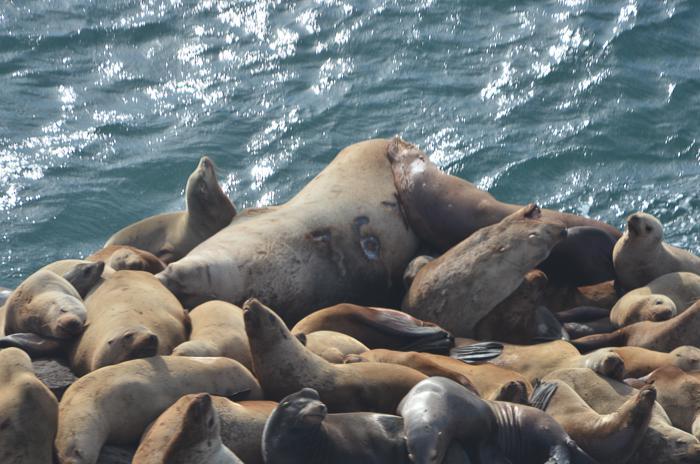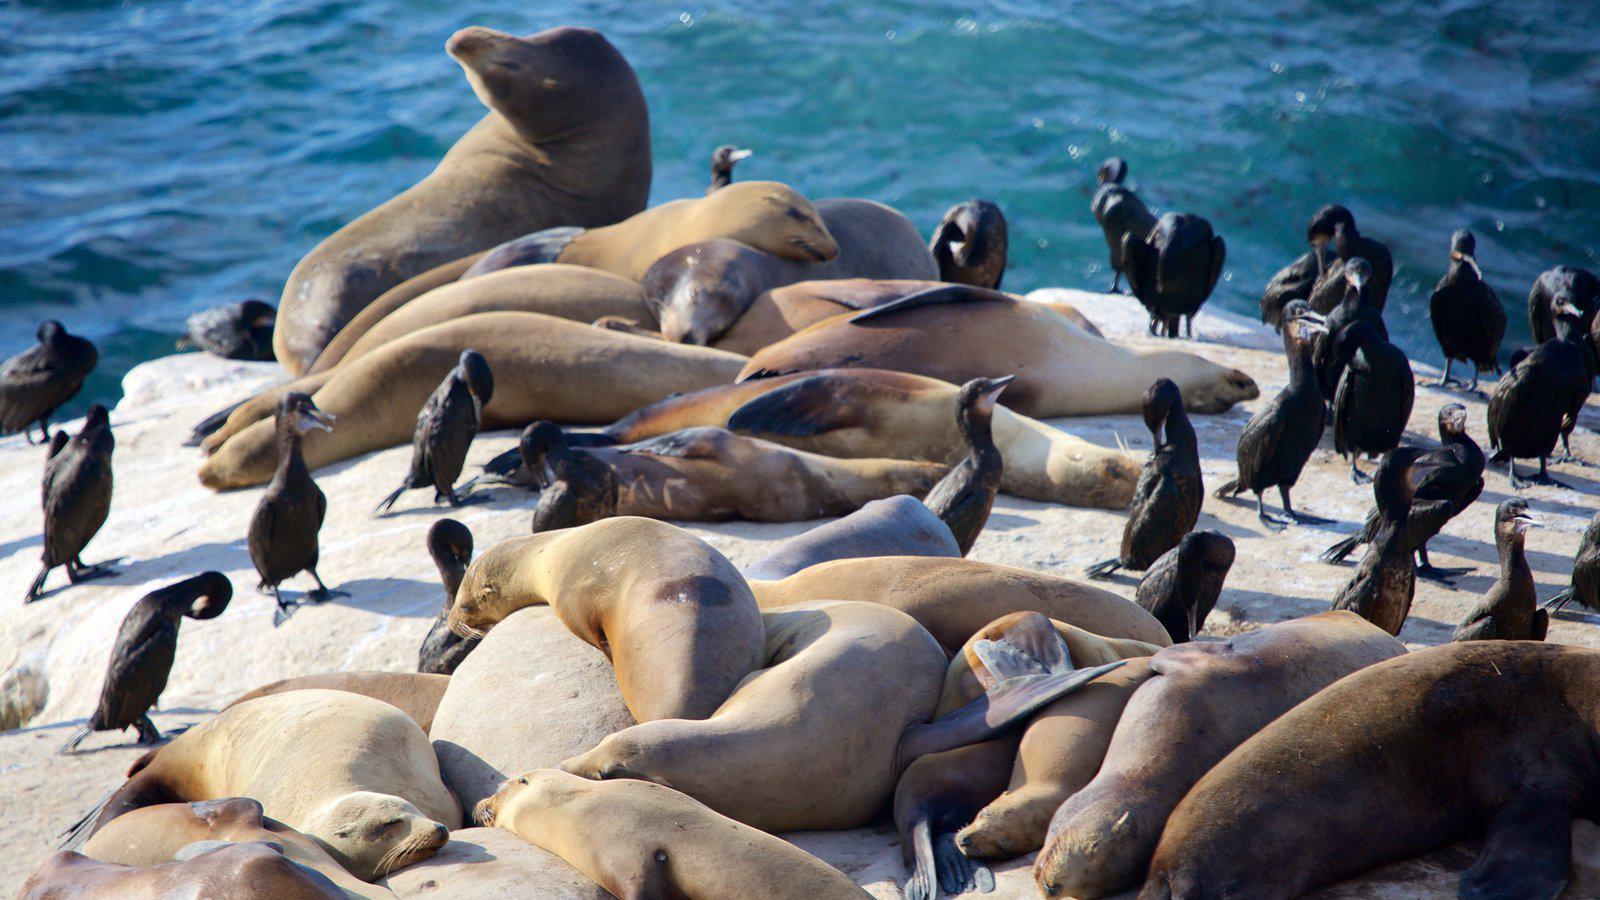The first image is the image on the left, the second image is the image on the right. Considering the images on both sides, is "There are no more than three seals sunning in one of the images." valid? Answer yes or no. No. The first image is the image on the left, the second image is the image on the right. Assess this claim about the two images: "No image contains more than seven seals, and at least one image shows seals on a rock above water.". Correct or not? Answer yes or no. No. 